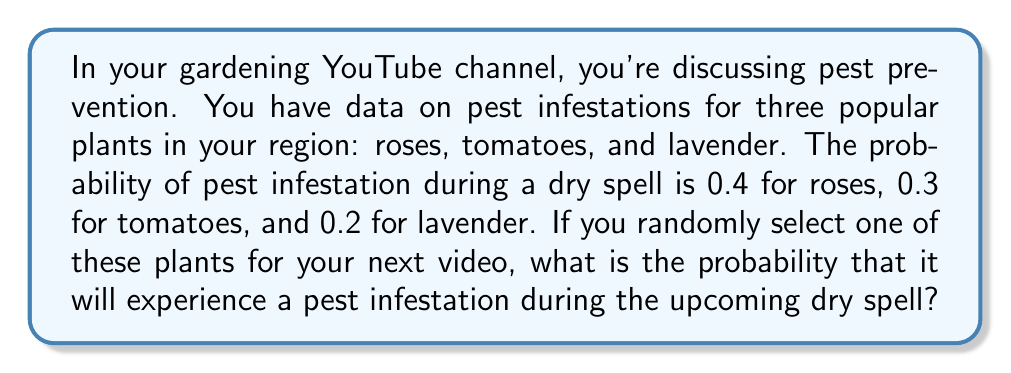Show me your answer to this math problem. Let's approach this step-by-step:

1) First, we need to understand that we're dealing with a simple probability problem where we have three equally likely outcomes (selecting rose, tomato, or lavender), each with its own probability of pest infestation.

2) The probability of selecting each plant is $\frac{1}{3}$, as we're randomly choosing one out of three plants.

3) Now, let's define our events:
   R: Selecting a rose
   T: Selecting a tomato
   L: Selecting a lavender
   P: Pest infestation occurs

4) We can use the law of total probability:

   $P(\text{Pest}) = P(P|R) \cdot P(R) + P(P|T) \cdot P(T) + P(P|L) \cdot P(L)$

   Where $P(P|R)$ means the probability of pest infestation given that we selected a rose, and so on.

5) Substituting the values:

   $P(\text{Pest}) = 0.4 \cdot \frac{1}{3} + 0.3 \cdot \frac{1}{3} + 0.2 \cdot \frac{1}{3}$

6) Simplifying:

   $P(\text{Pest}) = \frac{0.4 + 0.3 + 0.2}{3} = \frac{0.9}{3} = 0.3$

Therefore, the probability of pest infestation for a randomly selected plant during the dry spell is 0.3 or 30%.
Answer: 0.3 